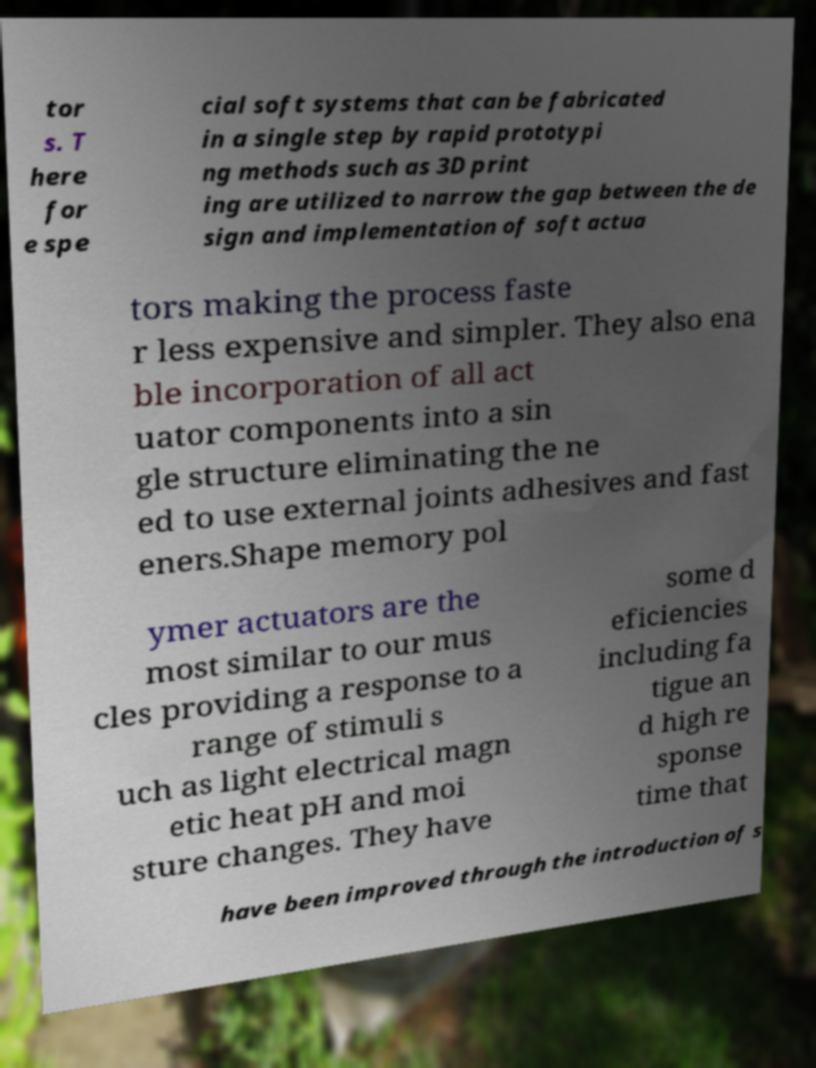I need the written content from this picture converted into text. Can you do that? tor s. T here for e spe cial soft systems that can be fabricated in a single step by rapid prototypi ng methods such as 3D print ing are utilized to narrow the gap between the de sign and implementation of soft actua tors making the process faste r less expensive and simpler. They also ena ble incorporation of all act uator components into a sin gle structure eliminating the ne ed to use external joints adhesives and fast eners.Shape memory pol ymer actuators are the most similar to our mus cles providing a response to a range of stimuli s uch as light electrical magn etic heat pH and moi sture changes. They have some d eficiencies including fa tigue an d high re sponse time that have been improved through the introduction of s 